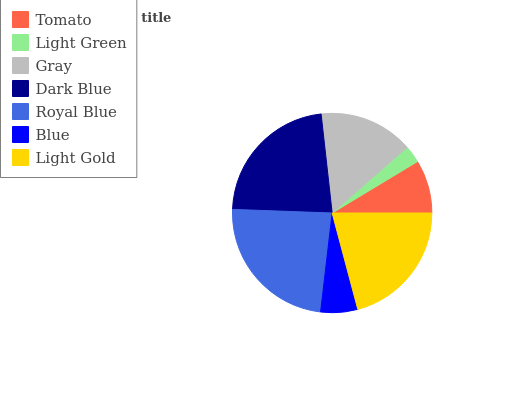Is Light Green the minimum?
Answer yes or no. Yes. Is Royal Blue the maximum?
Answer yes or no. Yes. Is Gray the minimum?
Answer yes or no. No. Is Gray the maximum?
Answer yes or no. No. Is Gray greater than Light Green?
Answer yes or no. Yes. Is Light Green less than Gray?
Answer yes or no. Yes. Is Light Green greater than Gray?
Answer yes or no. No. Is Gray less than Light Green?
Answer yes or no. No. Is Gray the high median?
Answer yes or no. Yes. Is Gray the low median?
Answer yes or no. Yes. Is Blue the high median?
Answer yes or no. No. Is Tomato the low median?
Answer yes or no. No. 